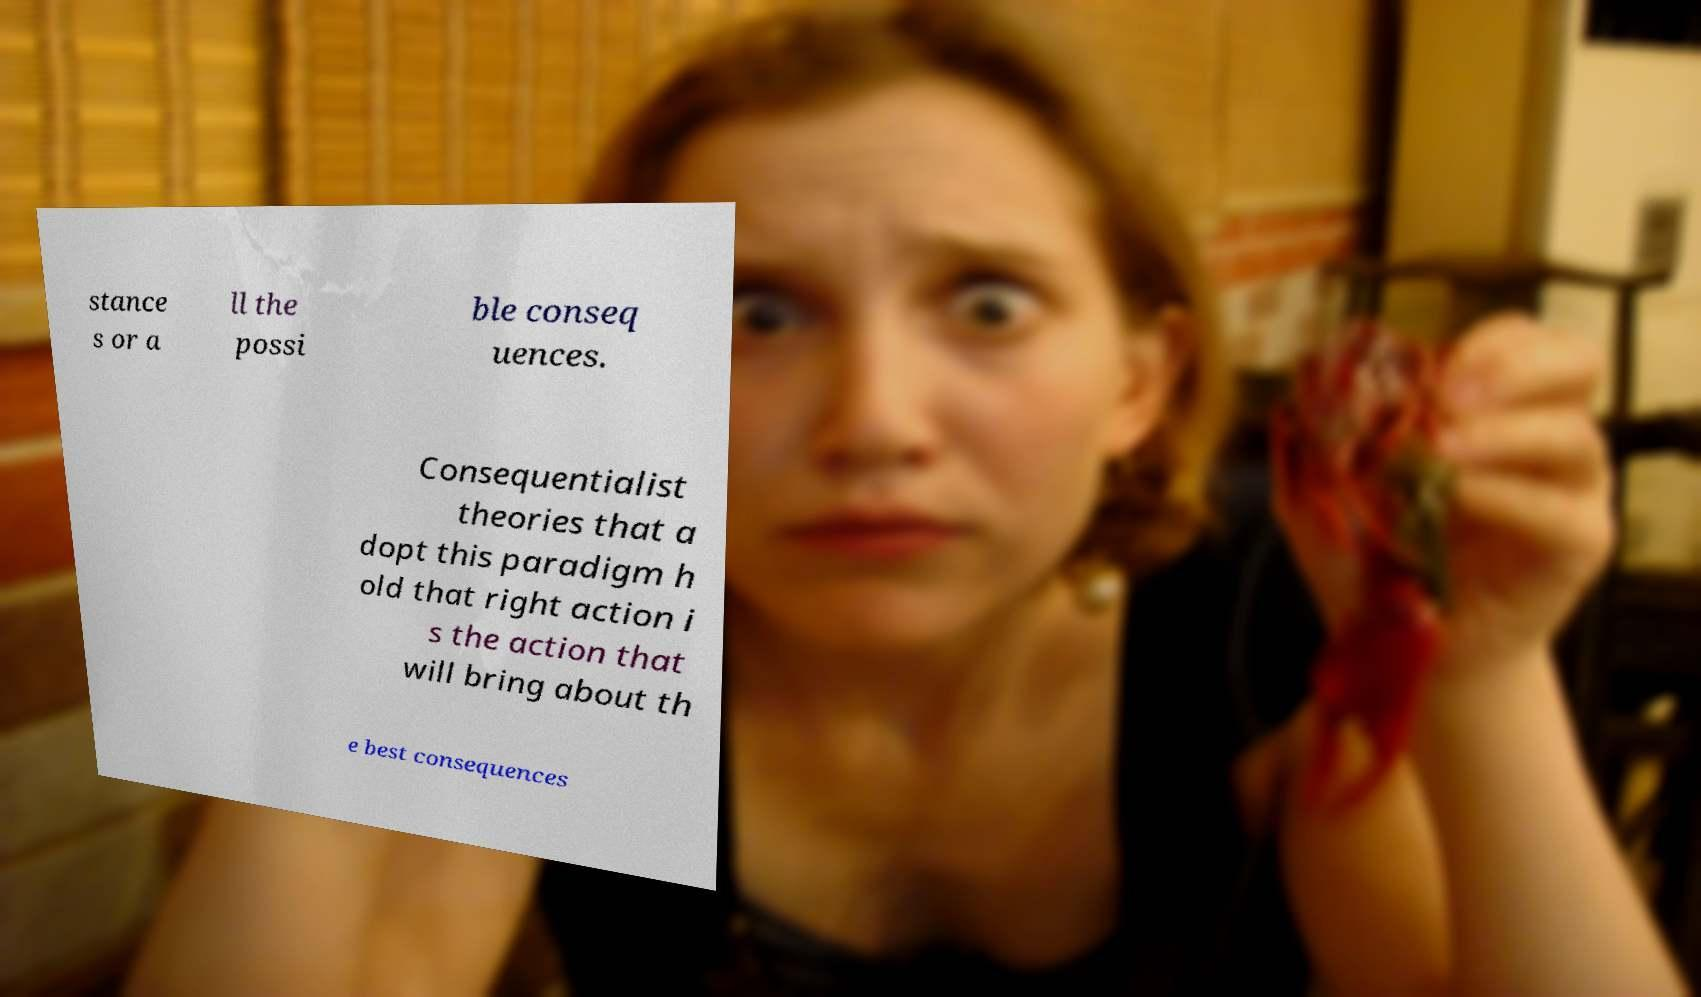Can you accurately transcribe the text from the provided image for me? stance s or a ll the possi ble conseq uences. Consequentialist theories that a dopt this paradigm h old that right action i s the action that will bring about th e best consequences 